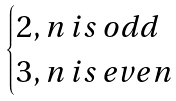<formula> <loc_0><loc_0><loc_500><loc_500>\begin{cases} 2 , n \, i s \, o d d \\ 3 , n \, i s \, e v e n \\ \end{cases}</formula> 